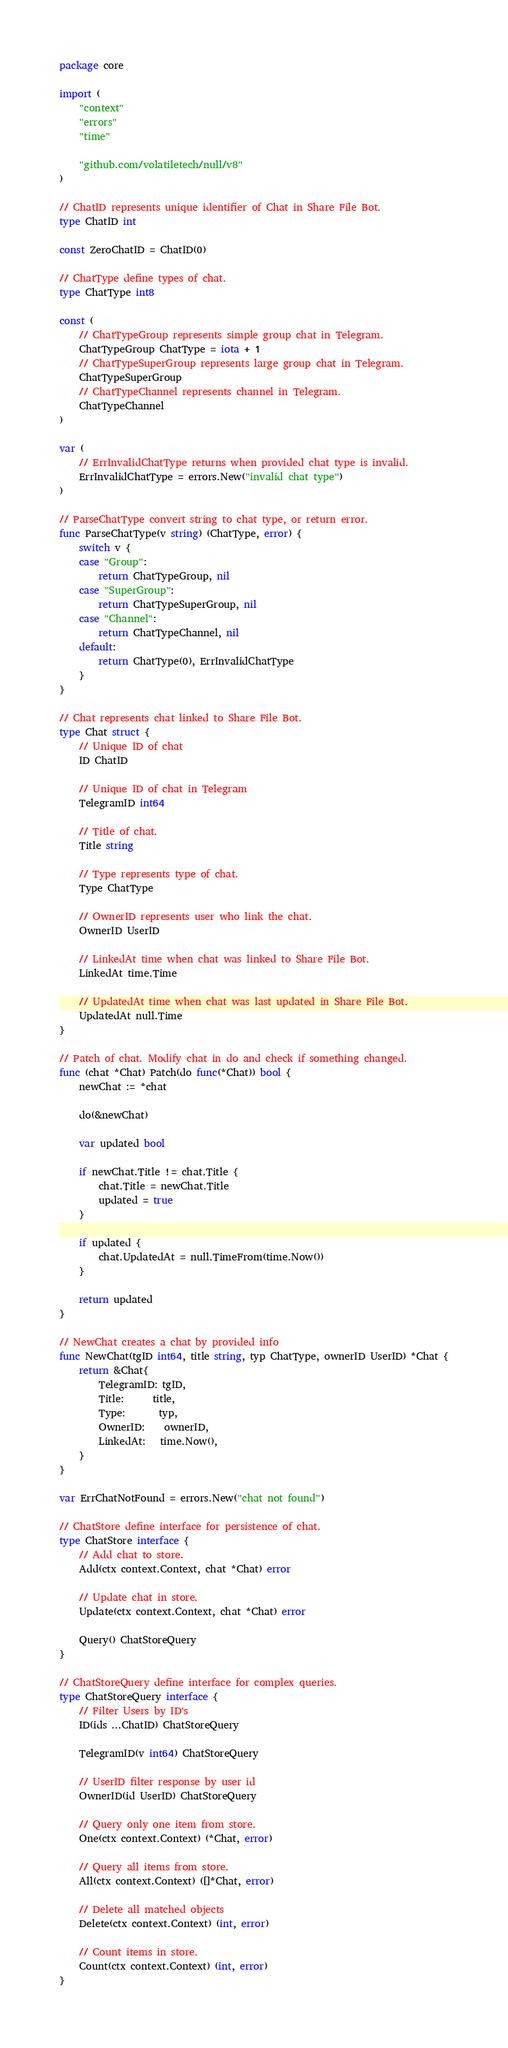Convert code to text. <code><loc_0><loc_0><loc_500><loc_500><_Go_>package core

import (
	"context"
	"errors"
	"time"

	"github.com/volatiletech/null/v8"
)

// ChatID represents unique identifier of Chat in Share File Bot.
type ChatID int

const ZeroChatID = ChatID(0)

// ChatType define types of chat.
type ChatType int8

const (
	// ChatTypeGroup represents simple group chat in Telegram.
	ChatTypeGroup ChatType = iota + 1
	// ChatTypeSuperGroup represents large group chat in Telegram.
	ChatTypeSuperGroup
	// ChatTypeChannel represents channel in Telegram.
	ChatTypeChannel
)

var (
	// ErrInvalidChatType returns when provided chat type is invalid.
	ErrInvalidChatType = errors.New("invalid chat type")
)

// ParseChatType convert string to chat type, or return error.
func ParseChatType(v string) (ChatType, error) {
	switch v {
	case "Group":
		return ChatTypeGroup, nil
	case "SuperGroup":
		return ChatTypeSuperGroup, nil
	case "Channel":
		return ChatTypeChannel, nil
	default:
		return ChatType(0), ErrInvalidChatType
	}
}

// Chat represents chat linked to Share File Bot.
type Chat struct {
	// Unique ID of chat
	ID ChatID

	// Unique ID of chat in Telegram
	TelegramID int64

	// Title of chat.
	Title string

	// Type represents type of chat.
	Type ChatType

	// OwnerID represents user who link the chat.
	OwnerID UserID

	// LinkedAt time when chat was linked to Share File Bot.
	LinkedAt time.Time

	// UpdatedAt time when chat was last updated in Share File Bot.
	UpdatedAt null.Time
}

// Patch of chat. Modify chat in do and check if something changed.
func (chat *Chat) Patch(do func(*Chat)) bool {
	newChat := *chat

	do(&newChat)

	var updated bool

	if newChat.Title != chat.Title {
		chat.Title = newChat.Title
		updated = true
	}

	if updated {
		chat.UpdatedAt = null.TimeFrom(time.Now())
	}

	return updated
}

// NewChat creates a chat by provided info
func NewChat(tgID int64, title string, typ ChatType, ownerID UserID) *Chat {
	return &Chat{
		TelegramID: tgID,
		Title:      title,
		Type:       typ,
		OwnerID:    ownerID,
		LinkedAt:   time.Now(),
	}
}

var ErrChatNotFound = errors.New("chat not found")

// ChatStore define interface for persistence of chat.
type ChatStore interface {
	// Add chat to store.
	Add(ctx context.Context, chat *Chat) error

	// Update chat in store.
	Update(ctx context.Context, chat *Chat) error

	Query() ChatStoreQuery
}

// ChatStoreQuery define interface for complex queries.
type ChatStoreQuery interface {
	// Filter Users by ID's
	ID(ids ...ChatID) ChatStoreQuery

	TelegramID(v int64) ChatStoreQuery

	// UserID filter response by user id
	OwnerID(id UserID) ChatStoreQuery

	// Query only one item from store.
	One(ctx context.Context) (*Chat, error)

	// Query all items from store.
	All(ctx context.Context) ([]*Chat, error)

	// Delete all matched objects
	Delete(ctx context.Context) (int, error)

	// Count items in store.
	Count(ctx context.Context) (int, error)
}
</code> 